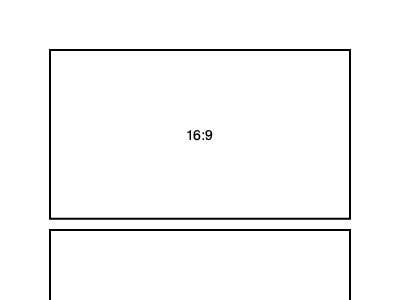As an aspiring film critic, you're analyzing the visual composition of classic and modern films. The diagram shows two common aspect ratios used in filmmaking. If a movie shot in 16:9 aspect ratio is to be displayed on a 4:3 screen without cropping, what percentage of the screen's vertical space would be filled by the movie? To solve this problem, we need to follow these steps:

1. Understand the aspect ratios:
   - 16:9 is a widescreen format (top rectangle)
   - 4:3 is a standard format (bottom rectangle)

2. Calculate the height of a 16:9 image when its width matches a 4:3 screen:
   - Let's assume the width is 4 units (to match the 4:3 ratio)
   - For 16:9 ratio: $\frac{width}{height} = \frac{16}{9}$
   - So, $\frac{4}{height} = \frac{16}{9}$
   - Cross multiply: $4 * 9 = 16 * height$
   - Solve for height: $height = \frac{4 * 9}{16} = 2.25$ units

3. Compare this height to the height of a 4:3 screen:
   - 4:3 screen height is 3 units (when width is 4)
   - 16:9 image height is 2.25 units

4. Calculate the percentage of vertical space filled:
   - $\frac{16:9\text{ height}}{4:3\text{ height}} * 100\% = \frac{2.25}{3} * 100\% = 0.75 * 100\% = 75\%$

Therefore, the 16:9 movie would fill 75% of the vertical space on a 4:3 screen, leaving black bars at the top and bottom.
Answer: 75% 